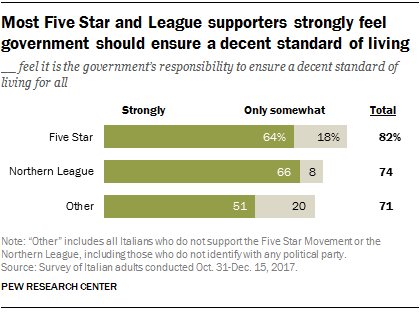Outline some significant characteristics in this image. The total of all the green bars is greater than 180. The total value of the Northern League is approximately 0.74. 